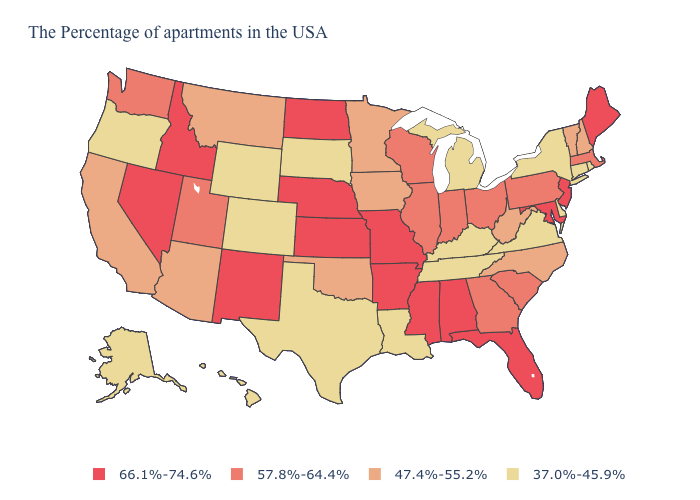What is the highest value in states that border Arizona?
Give a very brief answer. 66.1%-74.6%. Name the states that have a value in the range 37.0%-45.9%?
Concise answer only. Rhode Island, Connecticut, New York, Delaware, Virginia, Michigan, Kentucky, Tennessee, Louisiana, Texas, South Dakota, Wyoming, Colorado, Oregon, Alaska, Hawaii. What is the value of North Carolina?
Keep it brief. 47.4%-55.2%. Does the map have missing data?
Write a very short answer. No. Name the states that have a value in the range 57.8%-64.4%?
Write a very short answer. Massachusetts, Pennsylvania, South Carolina, Ohio, Georgia, Indiana, Wisconsin, Illinois, Utah, Washington. Among the states that border Mississippi , which have the lowest value?
Be succinct. Tennessee, Louisiana. What is the highest value in states that border Maryland?
Keep it brief. 57.8%-64.4%. Name the states that have a value in the range 47.4%-55.2%?
Concise answer only. New Hampshire, Vermont, North Carolina, West Virginia, Minnesota, Iowa, Oklahoma, Montana, Arizona, California. What is the lowest value in states that border Idaho?
Concise answer only. 37.0%-45.9%. Name the states that have a value in the range 37.0%-45.9%?
Short answer required. Rhode Island, Connecticut, New York, Delaware, Virginia, Michigan, Kentucky, Tennessee, Louisiana, Texas, South Dakota, Wyoming, Colorado, Oregon, Alaska, Hawaii. What is the value of Delaware?
Keep it brief. 37.0%-45.9%. What is the lowest value in the USA?
Write a very short answer. 37.0%-45.9%. What is the value of New Jersey?
Answer briefly. 66.1%-74.6%. Name the states that have a value in the range 57.8%-64.4%?
Quick response, please. Massachusetts, Pennsylvania, South Carolina, Ohio, Georgia, Indiana, Wisconsin, Illinois, Utah, Washington. 